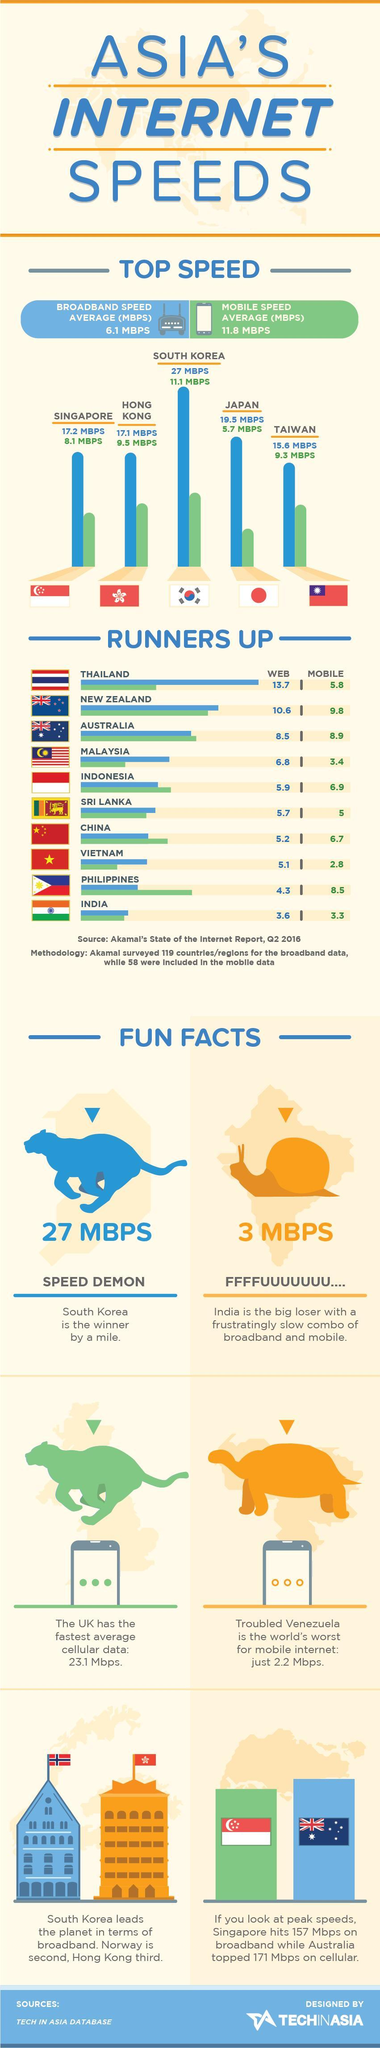What is the mobile internet speed (in Mbps) in China in Q2 2016?
Answer the question with a short phrase. 6.7 Which Asian country has the second highest broadband speed in Q2 2016? JAPAN Which Asian country has the highest broadband speed in Q2 2016? SOUTH KOREA What is the broadband internet speed (in Mbps) in Australia in Q2 2016? 8.5 Which Asian country has the second highest mobile internet speed in Q2 2016? HONG KONG What is the mobile internet speed (in Mbps) in Sri Lanka in Q2 2016? 5 